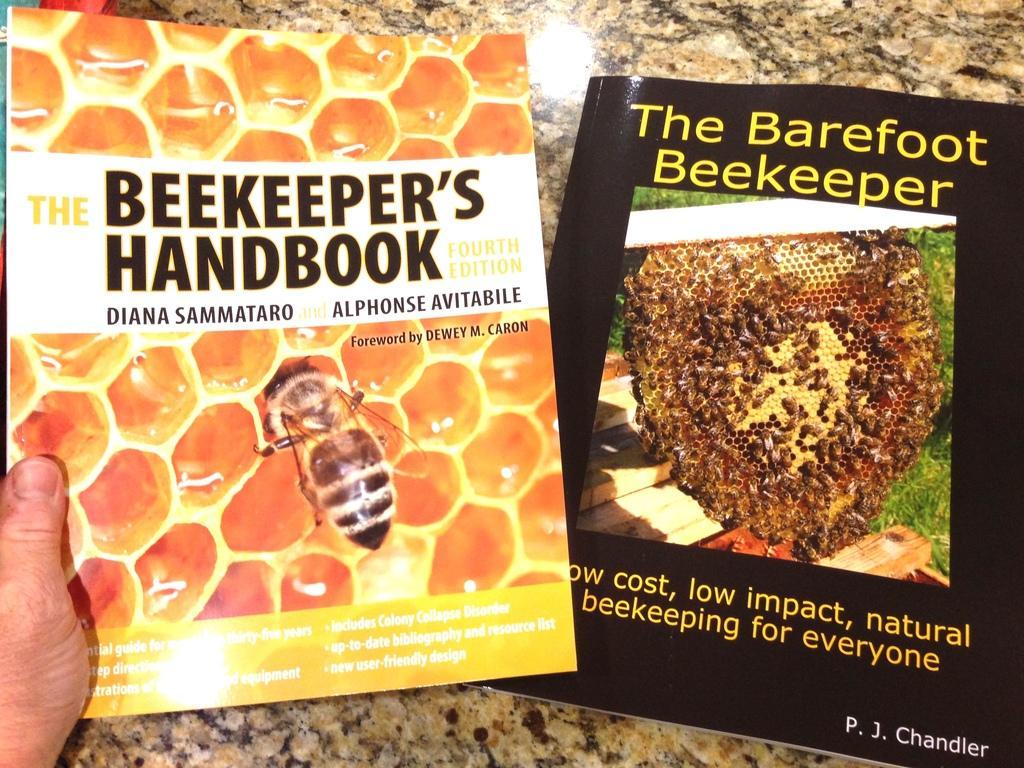Could you give a brief overview of what you see in this image? In this image, we can see a person's hand holding a book and there is an other book on the table. 